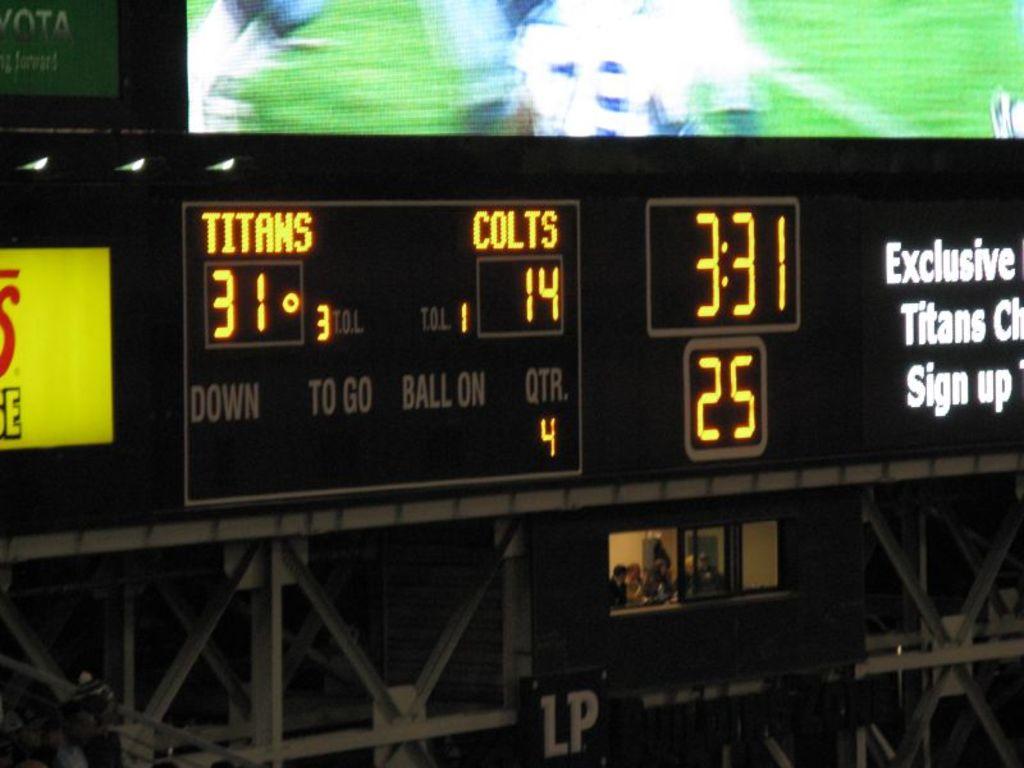Who is winning the game?
Keep it short and to the point. Titans. 